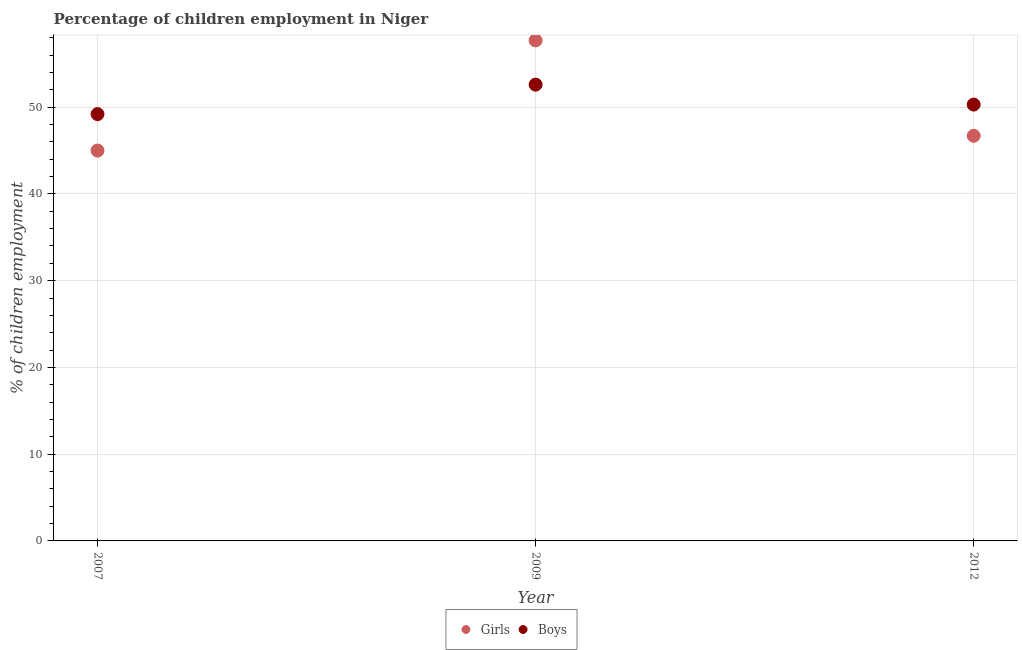Is the number of dotlines equal to the number of legend labels?
Ensure brevity in your answer.  Yes. What is the percentage of employed boys in 2012?
Your answer should be compact. 50.3. Across all years, what is the maximum percentage of employed girls?
Make the answer very short. 57.7. Across all years, what is the minimum percentage of employed girls?
Give a very brief answer. 45. What is the total percentage of employed girls in the graph?
Offer a terse response. 149.4. What is the difference between the percentage of employed boys in 2007 and that in 2012?
Give a very brief answer. -1.1. What is the difference between the percentage of employed girls in 2007 and the percentage of employed boys in 2009?
Your answer should be compact. -7.6. What is the average percentage of employed boys per year?
Your answer should be very brief. 50.7. In the year 2012, what is the difference between the percentage of employed boys and percentage of employed girls?
Your answer should be very brief. 3.6. What is the ratio of the percentage of employed boys in 2009 to that in 2012?
Ensure brevity in your answer.  1.05. What is the difference between the highest and the lowest percentage of employed girls?
Provide a succinct answer. 12.7. Is the sum of the percentage of employed boys in 2009 and 2012 greater than the maximum percentage of employed girls across all years?
Your response must be concise. Yes. Does the percentage of employed girls monotonically increase over the years?
Offer a terse response. No. How many dotlines are there?
Provide a succinct answer. 2. Where does the legend appear in the graph?
Provide a succinct answer. Bottom center. How are the legend labels stacked?
Your response must be concise. Horizontal. What is the title of the graph?
Offer a terse response. Percentage of children employment in Niger. What is the label or title of the X-axis?
Keep it short and to the point. Year. What is the label or title of the Y-axis?
Ensure brevity in your answer.  % of children employment. What is the % of children employment of Boys in 2007?
Provide a succinct answer. 49.2. What is the % of children employment of Girls in 2009?
Offer a terse response. 57.7. What is the % of children employment in Boys in 2009?
Ensure brevity in your answer.  52.6. What is the % of children employment in Girls in 2012?
Provide a short and direct response. 46.7. What is the % of children employment of Boys in 2012?
Keep it short and to the point. 50.3. Across all years, what is the maximum % of children employment of Girls?
Offer a very short reply. 57.7. Across all years, what is the maximum % of children employment in Boys?
Keep it short and to the point. 52.6. Across all years, what is the minimum % of children employment of Girls?
Ensure brevity in your answer.  45. Across all years, what is the minimum % of children employment in Boys?
Keep it short and to the point. 49.2. What is the total % of children employment of Girls in the graph?
Your response must be concise. 149.4. What is the total % of children employment of Boys in the graph?
Your answer should be compact. 152.1. What is the difference between the % of children employment of Boys in 2007 and that in 2009?
Your answer should be compact. -3.4. What is the difference between the % of children employment in Boys in 2007 and that in 2012?
Keep it short and to the point. -1.1. What is the difference between the % of children employment of Boys in 2009 and that in 2012?
Give a very brief answer. 2.3. What is the difference between the % of children employment in Girls in 2007 and the % of children employment in Boys in 2012?
Offer a very short reply. -5.3. What is the average % of children employment of Girls per year?
Keep it short and to the point. 49.8. What is the average % of children employment in Boys per year?
Your response must be concise. 50.7. What is the ratio of the % of children employment in Girls in 2007 to that in 2009?
Ensure brevity in your answer.  0.78. What is the ratio of the % of children employment in Boys in 2007 to that in 2009?
Make the answer very short. 0.94. What is the ratio of the % of children employment in Girls in 2007 to that in 2012?
Your answer should be very brief. 0.96. What is the ratio of the % of children employment of Boys in 2007 to that in 2012?
Your answer should be very brief. 0.98. What is the ratio of the % of children employment in Girls in 2009 to that in 2012?
Your answer should be very brief. 1.24. What is the ratio of the % of children employment of Boys in 2009 to that in 2012?
Ensure brevity in your answer.  1.05. What is the difference between the highest and the second highest % of children employment of Girls?
Provide a succinct answer. 11. What is the difference between the highest and the lowest % of children employment in Girls?
Provide a succinct answer. 12.7. What is the difference between the highest and the lowest % of children employment of Boys?
Ensure brevity in your answer.  3.4. 